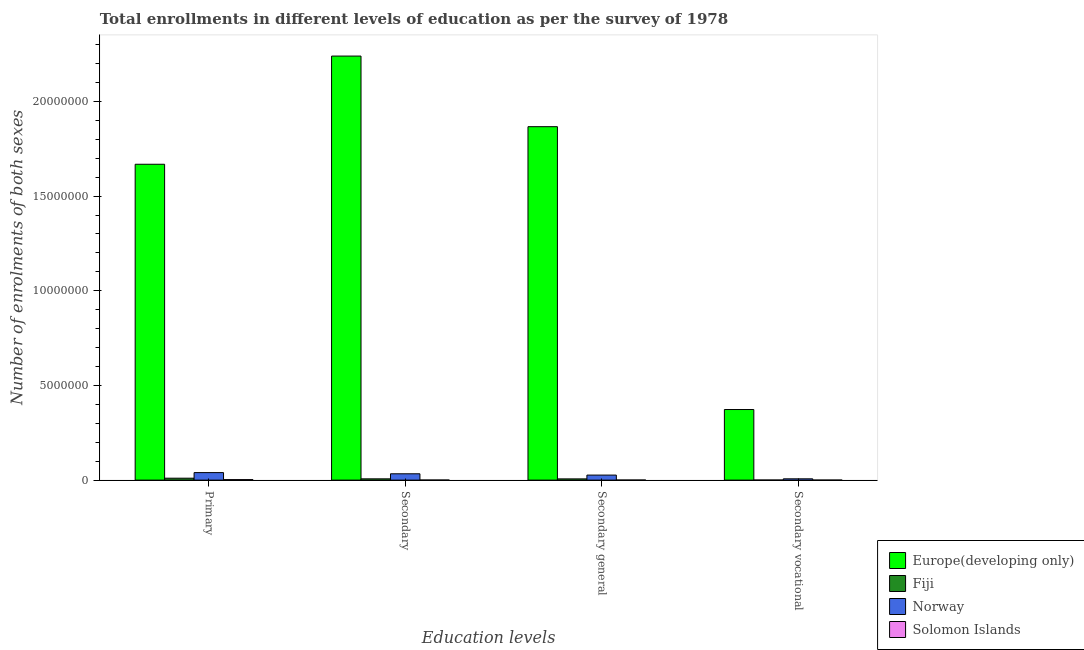How many bars are there on the 3rd tick from the left?
Ensure brevity in your answer.  4. What is the label of the 4th group of bars from the left?
Keep it short and to the point. Secondary vocational. What is the number of enrolments in secondary vocational education in Solomon Islands?
Your answer should be compact. 484. Across all countries, what is the maximum number of enrolments in secondary general education?
Provide a succinct answer. 1.87e+07. Across all countries, what is the minimum number of enrolments in secondary general education?
Provide a succinct answer. 2984. In which country was the number of enrolments in secondary education maximum?
Provide a short and direct response. Europe(developing only). In which country was the number of enrolments in secondary vocational education minimum?
Keep it short and to the point. Solomon Islands. What is the total number of enrolments in primary education in the graph?
Your answer should be very brief. 1.72e+07. What is the difference between the number of enrolments in secondary vocational education in Fiji and that in Solomon Islands?
Your answer should be very brief. 2059. What is the difference between the number of enrolments in secondary vocational education in Solomon Islands and the number of enrolments in secondary education in Fiji?
Make the answer very short. -6.68e+04. What is the average number of enrolments in secondary general education per country?
Provide a short and direct response. 4.75e+06. What is the difference between the number of enrolments in secondary general education and number of enrolments in primary education in Fiji?
Keep it short and to the point. -3.64e+04. What is the ratio of the number of enrolments in secondary general education in Solomon Islands to that in Fiji?
Provide a short and direct response. 0.05. Is the number of enrolments in primary education in Solomon Islands less than that in Europe(developing only)?
Provide a succinct answer. Yes. Is the difference between the number of enrolments in secondary vocational education in Norway and Solomon Islands greater than the difference between the number of enrolments in secondary education in Norway and Solomon Islands?
Your answer should be compact. No. What is the difference between the highest and the second highest number of enrolments in primary education?
Offer a terse response. 1.63e+07. What is the difference between the highest and the lowest number of enrolments in secondary vocational education?
Give a very brief answer. 3.73e+06. In how many countries, is the number of enrolments in secondary general education greater than the average number of enrolments in secondary general education taken over all countries?
Give a very brief answer. 1. Is it the case that in every country, the sum of the number of enrolments in primary education and number of enrolments in secondary education is greater than the number of enrolments in secondary general education?
Offer a very short reply. Yes. How many bars are there?
Provide a succinct answer. 16. How many countries are there in the graph?
Ensure brevity in your answer.  4. What is the difference between two consecutive major ticks on the Y-axis?
Your response must be concise. 5.00e+06. Does the graph contain grids?
Keep it short and to the point. No. How many legend labels are there?
Provide a short and direct response. 4. What is the title of the graph?
Provide a short and direct response. Total enrollments in different levels of education as per the survey of 1978. What is the label or title of the X-axis?
Your answer should be very brief. Education levels. What is the label or title of the Y-axis?
Your response must be concise. Number of enrolments of both sexes. What is the Number of enrolments of both sexes in Europe(developing only) in Primary?
Ensure brevity in your answer.  1.67e+07. What is the Number of enrolments of both sexes of Fiji in Primary?
Your answer should be very brief. 1.01e+05. What is the Number of enrolments of both sexes in Norway in Primary?
Your response must be concise. 3.97e+05. What is the Number of enrolments of both sexes in Solomon Islands in Primary?
Provide a succinct answer. 2.67e+04. What is the Number of enrolments of both sexes of Europe(developing only) in Secondary?
Provide a succinct answer. 2.24e+07. What is the Number of enrolments of both sexes of Fiji in Secondary?
Provide a succinct answer. 6.73e+04. What is the Number of enrolments of both sexes in Norway in Secondary?
Provide a short and direct response. 3.34e+05. What is the Number of enrolments of both sexes of Solomon Islands in Secondary?
Offer a very short reply. 3468. What is the Number of enrolments of both sexes in Europe(developing only) in Secondary general?
Make the answer very short. 1.87e+07. What is the Number of enrolments of both sexes of Fiji in Secondary general?
Keep it short and to the point. 6.48e+04. What is the Number of enrolments of both sexes in Norway in Secondary general?
Your answer should be compact. 2.66e+05. What is the Number of enrolments of both sexes in Solomon Islands in Secondary general?
Ensure brevity in your answer.  2984. What is the Number of enrolments of both sexes of Europe(developing only) in Secondary vocational?
Your response must be concise. 3.73e+06. What is the Number of enrolments of both sexes in Fiji in Secondary vocational?
Make the answer very short. 2543. What is the Number of enrolments of both sexes in Norway in Secondary vocational?
Offer a terse response. 6.87e+04. What is the Number of enrolments of both sexes of Solomon Islands in Secondary vocational?
Your answer should be very brief. 484. Across all Education levels, what is the maximum Number of enrolments of both sexes of Europe(developing only)?
Offer a very short reply. 2.24e+07. Across all Education levels, what is the maximum Number of enrolments of both sexes in Fiji?
Provide a succinct answer. 1.01e+05. Across all Education levels, what is the maximum Number of enrolments of both sexes in Norway?
Keep it short and to the point. 3.97e+05. Across all Education levels, what is the maximum Number of enrolments of both sexes in Solomon Islands?
Offer a very short reply. 2.67e+04. Across all Education levels, what is the minimum Number of enrolments of both sexes in Europe(developing only)?
Give a very brief answer. 3.73e+06. Across all Education levels, what is the minimum Number of enrolments of both sexes of Fiji?
Provide a succinct answer. 2543. Across all Education levels, what is the minimum Number of enrolments of both sexes in Norway?
Provide a succinct answer. 6.87e+04. Across all Education levels, what is the minimum Number of enrolments of both sexes of Solomon Islands?
Provide a succinct answer. 484. What is the total Number of enrolments of both sexes in Europe(developing only) in the graph?
Provide a succinct answer. 6.15e+07. What is the total Number of enrolments of both sexes in Fiji in the graph?
Make the answer very short. 2.36e+05. What is the total Number of enrolments of both sexes in Norway in the graph?
Your response must be concise. 1.07e+06. What is the total Number of enrolments of both sexes in Solomon Islands in the graph?
Keep it short and to the point. 3.37e+04. What is the difference between the Number of enrolments of both sexes in Europe(developing only) in Primary and that in Secondary?
Keep it short and to the point. -5.71e+06. What is the difference between the Number of enrolments of both sexes in Fiji in Primary and that in Secondary?
Provide a succinct answer. 3.38e+04. What is the difference between the Number of enrolments of both sexes in Norway in Primary and that in Secondary?
Provide a succinct answer. 6.23e+04. What is the difference between the Number of enrolments of both sexes in Solomon Islands in Primary and that in Secondary?
Your answer should be compact. 2.33e+04. What is the difference between the Number of enrolments of both sexes in Europe(developing only) in Primary and that in Secondary general?
Give a very brief answer. -1.98e+06. What is the difference between the Number of enrolments of both sexes in Fiji in Primary and that in Secondary general?
Offer a terse response. 3.64e+04. What is the difference between the Number of enrolments of both sexes in Norway in Primary and that in Secondary general?
Offer a terse response. 1.31e+05. What is the difference between the Number of enrolments of both sexes of Solomon Islands in Primary and that in Secondary general?
Provide a short and direct response. 2.38e+04. What is the difference between the Number of enrolments of both sexes of Europe(developing only) in Primary and that in Secondary vocational?
Your answer should be very brief. 1.30e+07. What is the difference between the Number of enrolments of both sexes in Fiji in Primary and that in Secondary vocational?
Provide a succinct answer. 9.86e+04. What is the difference between the Number of enrolments of both sexes of Norway in Primary and that in Secondary vocational?
Offer a terse response. 3.28e+05. What is the difference between the Number of enrolments of both sexes in Solomon Islands in Primary and that in Secondary vocational?
Offer a terse response. 2.63e+04. What is the difference between the Number of enrolments of both sexes of Europe(developing only) in Secondary and that in Secondary general?
Offer a terse response. 3.73e+06. What is the difference between the Number of enrolments of both sexes in Fiji in Secondary and that in Secondary general?
Ensure brevity in your answer.  2543. What is the difference between the Number of enrolments of both sexes of Norway in Secondary and that in Secondary general?
Ensure brevity in your answer.  6.87e+04. What is the difference between the Number of enrolments of both sexes of Solomon Islands in Secondary and that in Secondary general?
Make the answer very short. 484. What is the difference between the Number of enrolments of both sexes of Europe(developing only) in Secondary and that in Secondary vocational?
Offer a terse response. 1.87e+07. What is the difference between the Number of enrolments of both sexes of Fiji in Secondary and that in Secondary vocational?
Your answer should be very brief. 6.48e+04. What is the difference between the Number of enrolments of both sexes of Norway in Secondary and that in Secondary vocational?
Provide a succinct answer. 2.66e+05. What is the difference between the Number of enrolments of both sexes of Solomon Islands in Secondary and that in Secondary vocational?
Provide a short and direct response. 2984. What is the difference between the Number of enrolments of both sexes of Europe(developing only) in Secondary general and that in Secondary vocational?
Your response must be concise. 1.49e+07. What is the difference between the Number of enrolments of both sexes in Fiji in Secondary general and that in Secondary vocational?
Your response must be concise. 6.22e+04. What is the difference between the Number of enrolments of both sexes in Norway in Secondary general and that in Secondary vocational?
Provide a short and direct response. 1.97e+05. What is the difference between the Number of enrolments of both sexes of Solomon Islands in Secondary general and that in Secondary vocational?
Offer a terse response. 2500. What is the difference between the Number of enrolments of both sexes of Europe(developing only) in Primary and the Number of enrolments of both sexes of Fiji in Secondary?
Provide a succinct answer. 1.66e+07. What is the difference between the Number of enrolments of both sexes of Europe(developing only) in Primary and the Number of enrolments of both sexes of Norway in Secondary?
Provide a succinct answer. 1.63e+07. What is the difference between the Number of enrolments of both sexes in Europe(developing only) in Primary and the Number of enrolments of both sexes in Solomon Islands in Secondary?
Provide a short and direct response. 1.67e+07. What is the difference between the Number of enrolments of both sexes in Fiji in Primary and the Number of enrolments of both sexes in Norway in Secondary?
Ensure brevity in your answer.  -2.33e+05. What is the difference between the Number of enrolments of both sexes in Fiji in Primary and the Number of enrolments of both sexes in Solomon Islands in Secondary?
Provide a short and direct response. 9.77e+04. What is the difference between the Number of enrolments of both sexes in Norway in Primary and the Number of enrolments of both sexes in Solomon Islands in Secondary?
Make the answer very short. 3.93e+05. What is the difference between the Number of enrolments of both sexes of Europe(developing only) in Primary and the Number of enrolments of both sexes of Fiji in Secondary general?
Ensure brevity in your answer.  1.66e+07. What is the difference between the Number of enrolments of both sexes of Europe(developing only) in Primary and the Number of enrolments of both sexes of Norway in Secondary general?
Offer a terse response. 1.64e+07. What is the difference between the Number of enrolments of both sexes of Europe(developing only) in Primary and the Number of enrolments of both sexes of Solomon Islands in Secondary general?
Provide a succinct answer. 1.67e+07. What is the difference between the Number of enrolments of both sexes in Fiji in Primary and the Number of enrolments of both sexes in Norway in Secondary general?
Give a very brief answer. -1.65e+05. What is the difference between the Number of enrolments of both sexes of Fiji in Primary and the Number of enrolments of both sexes of Solomon Islands in Secondary general?
Provide a succinct answer. 9.82e+04. What is the difference between the Number of enrolments of both sexes of Norway in Primary and the Number of enrolments of both sexes of Solomon Islands in Secondary general?
Your response must be concise. 3.94e+05. What is the difference between the Number of enrolments of both sexes in Europe(developing only) in Primary and the Number of enrolments of both sexes in Fiji in Secondary vocational?
Your response must be concise. 1.67e+07. What is the difference between the Number of enrolments of both sexes of Europe(developing only) in Primary and the Number of enrolments of both sexes of Norway in Secondary vocational?
Your answer should be compact. 1.66e+07. What is the difference between the Number of enrolments of both sexes of Europe(developing only) in Primary and the Number of enrolments of both sexes of Solomon Islands in Secondary vocational?
Ensure brevity in your answer.  1.67e+07. What is the difference between the Number of enrolments of both sexes in Fiji in Primary and the Number of enrolments of both sexes in Norway in Secondary vocational?
Make the answer very short. 3.25e+04. What is the difference between the Number of enrolments of both sexes in Fiji in Primary and the Number of enrolments of both sexes in Solomon Islands in Secondary vocational?
Provide a succinct answer. 1.01e+05. What is the difference between the Number of enrolments of both sexes in Norway in Primary and the Number of enrolments of both sexes in Solomon Islands in Secondary vocational?
Offer a terse response. 3.96e+05. What is the difference between the Number of enrolments of both sexes of Europe(developing only) in Secondary and the Number of enrolments of both sexes of Fiji in Secondary general?
Give a very brief answer. 2.23e+07. What is the difference between the Number of enrolments of both sexes of Europe(developing only) in Secondary and the Number of enrolments of both sexes of Norway in Secondary general?
Offer a terse response. 2.21e+07. What is the difference between the Number of enrolments of both sexes in Europe(developing only) in Secondary and the Number of enrolments of both sexes in Solomon Islands in Secondary general?
Your answer should be compact. 2.24e+07. What is the difference between the Number of enrolments of both sexes in Fiji in Secondary and the Number of enrolments of both sexes in Norway in Secondary general?
Provide a succinct answer. -1.98e+05. What is the difference between the Number of enrolments of both sexes in Fiji in Secondary and the Number of enrolments of both sexes in Solomon Islands in Secondary general?
Keep it short and to the point. 6.43e+04. What is the difference between the Number of enrolments of both sexes in Norway in Secondary and the Number of enrolments of both sexes in Solomon Islands in Secondary general?
Give a very brief answer. 3.31e+05. What is the difference between the Number of enrolments of both sexes in Europe(developing only) in Secondary and the Number of enrolments of both sexes in Fiji in Secondary vocational?
Your response must be concise. 2.24e+07. What is the difference between the Number of enrolments of both sexes in Europe(developing only) in Secondary and the Number of enrolments of both sexes in Norway in Secondary vocational?
Ensure brevity in your answer.  2.23e+07. What is the difference between the Number of enrolments of both sexes of Europe(developing only) in Secondary and the Number of enrolments of both sexes of Solomon Islands in Secondary vocational?
Offer a very short reply. 2.24e+07. What is the difference between the Number of enrolments of both sexes in Fiji in Secondary and the Number of enrolments of both sexes in Norway in Secondary vocational?
Ensure brevity in your answer.  -1350. What is the difference between the Number of enrolments of both sexes of Fiji in Secondary and the Number of enrolments of both sexes of Solomon Islands in Secondary vocational?
Keep it short and to the point. 6.68e+04. What is the difference between the Number of enrolments of both sexes of Norway in Secondary and the Number of enrolments of both sexes of Solomon Islands in Secondary vocational?
Give a very brief answer. 3.34e+05. What is the difference between the Number of enrolments of both sexes in Europe(developing only) in Secondary general and the Number of enrolments of both sexes in Fiji in Secondary vocational?
Your response must be concise. 1.87e+07. What is the difference between the Number of enrolments of both sexes in Europe(developing only) in Secondary general and the Number of enrolments of both sexes in Norway in Secondary vocational?
Your answer should be very brief. 1.86e+07. What is the difference between the Number of enrolments of both sexes in Europe(developing only) in Secondary general and the Number of enrolments of both sexes in Solomon Islands in Secondary vocational?
Give a very brief answer. 1.87e+07. What is the difference between the Number of enrolments of both sexes in Fiji in Secondary general and the Number of enrolments of both sexes in Norway in Secondary vocational?
Offer a terse response. -3893. What is the difference between the Number of enrolments of both sexes in Fiji in Secondary general and the Number of enrolments of both sexes in Solomon Islands in Secondary vocational?
Your answer should be very brief. 6.43e+04. What is the difference between the Number of enrolments of both sexes of Norway in Secondary general and the Number of enrolments of both sexes of Solomon Islands in Secondary vocational?
Keep it short and to the point. 2.65e+05. What is the average Number of enrolments of both sexes of Europe(developing only) per Education levels?
Give a very brief answer. 1.54e+07. What is the average Number of enrolments of both sexes in Fiji per Education levels?
Offer a terse response. 5.90e+04. What is the average Number of enrolments of both sexes in Norway per Education levels?
Offer a terse response. 2.66e+05. What is the average Number of enrolments of both sexes of Solomon Islands per Education levels?
Your answer should be very brief. 8421.25. What is the difference between the Number of enrolments of both sexes in Europe(developing only) and Number of enrolments of both sexes in Fiji in Primary?
Ensure brevity in your answer.  1.66e+07. What is the difference between the Number of enrolments of both sexes of Europe(developing only) and Number of enrolments of both sexes of Norway in Primary?
Make the answer very short. 1.63e+07. What is the difference between the Number of enrolments of both sexes in Europe(developing only) and Number of enrolments of both sexes in Solomon Islands in Primary?
Provide a short and direct response. 1.67e+07. What is the difference between the Number of enrolments of both sexes in Fiji and Number of enrolments of both sexes in Norway in Primary?
Keep it short and to the point. -2.96e+05. What is the difference between the Number of enrolments of both sexes of Fiji and Number of enrolments of both sexes of Solomon Islands in Primary?
Your answer should be very brief. 7.44e+04. What is the difference between the Number of enrolments of both sexes of Norway and Number of enrolments of both sexes of Solomon Islands in Primary?
Your answer should be compact. 3.70e+05. What is the difference between the Number of enrolments of both sexes of Europe(developing only) and Number of enrolments of both sexes of Fiji in Secondary?
Offer a very short reply. 2.23e+07. What is the difference between the Number of enrolments of both sexes in Europe(developing only) and Number of enrolments of both sexes in Norway in Secondary?
Provide a succinct answer. 2.21e+07. What is the difference between the Number of enrolments of both sexes of Europe(developing only) and Number of enrolments of both sexes of Solomon Islands in Secondary?
Make the answer very short. 2.24e+07. What is the difference between the Number of enrolments of both sexes in Fiji and Number of enrolments of both sexes in Norway in Secondary?
Offer a terse response. -2.67e+05. What is the difference between the Number of enrolments of both sexes of Fiji and Number of enrolments of both sexes of Solomon Islands in Secondary?
Give a very brief answer. 6.39e+04. What is the difference between the Number of enrolments of both sexes of Norway and Number of enrolments of both sexes of Solomon Islands in Secondary?
Give a very brief answer. 3.31e+05. What is the difference between the Number of enrolments of both sexes of Europe(developing only) and Number of enrolments of both sexes of Fiji in Secondary general?
Provide a succinct answer. 1.86e+07. What is the difference between the Number of enrolments of both sexes in Europe(developing only) and Number of enrolments of both sexes in Norway in Secondary general?
Offer a very short reply. 1.84e+07. What is the difference between the Number of enrolments of both sexes of Europe(developing only) and Number of enrolments of both sexes of Solomon Islands in Secondary general?
Give a very brief answer. 1.87e+07. What is the difference between the Number of enrolments of both sexes in Fiji and Number of enrolments of both sexes in Norway in Secondary general?
Give a very brief answer. -2.01e+05. What is the difference between the Number of enrolments of both sexes of Fiji and Number of enrolments of both sexes of Solomon Islands in Secondary general?
Your response must be concise. 6.18e+04. What is the difference between the Number of enrolments of both sexes in Norway and Number of enrolments of both sexes in Solomon Islands in Secondary general?
Your response must be concise. 2.63e+05. What is the difference between the Number of enrolments of both sexes in Europe(developing only) and Number of enrolments of both sexes in Fiji in Secondary vocational?
Give a very brief answer. 3.73e+06. What is the difference between the Number of enrolments of both sexes in Europe(developing only) and Number of enrolments of both sexes in Norway in Secondary vocational?
Your response must be concise. 3.66e+06. What is the difference between the Number of enrolments of both sexes in Europe(developing only) and Number of enrolments of both sexes in Solomon Islands in Secondary vocational?
Make the answer very short. 3.73e+06. What is the difference between the Number of enrolments of both sexes in Fiji and Number of enrolments of both sexes in Norway in Secondary vocational?
Provide a short and direct response. -6.61e+04. What is the difference between the Number of enrolments of both sexes of Fiji and Number of enrolments of both sexes of Solomon Islands in Secondary vocational?
Give a very brief answer. 2059. What is the difference between the Number of enrolments of both sexes in Norway and Number of enrolments of both sexes in Solomon Islands in Secondary vocational?
Provide a short and direct response. 6.82e+04. What is the ratio of the Number of enrolments of both sexes in Europe(developing only) in Primary to that in Secondary?
Your answer should be very brief. 0.74. What is the ratio of the Number of enrolments of both sexes in Fiji in Primary to that in Secondary?
Your response must be concise. 1.5. What is the ratio of the Number of enrolments of both sexes of Norway in Primary to that in Secondary?
Your response must be concise. 1.19. What is the ratio of the Number of enrolments of both sexes of Solomon Islands in Primary to that in Secondary?
Make the answer very short. 7.71. What is the ratio of the Number of enrolments of both sexes of Europe(developing only) in Primary to that in Secondary general?
Your response must be concise. 0.89. What is the ratio of the Number of enrolments of both sexes of Fiji in Primary to that in Secondary general?
Ensure brevity in your answer.  1.56. What is the ratio of the Number of enrolments of both sexes in Norway in Primary to that in Secondary general?
Your answer should be compact. 1.49. What is the ratio of the Number of enrolments of both sexes in Solomon Islands in Primary to that in Secondary general?
Your answer should be very brief. 8.96. What is the ratio of the Number of enrolments of both sexes in Europe(developing only) in Primary to that in Secondary vocational?
Give a very brief answer. 4.47. What is the ratio of the Number of enrolments of both sexes of Fiji in Primary to that in Secondary vocational?
Make the answer very short. 39.78. What is the ratio of the Number of enrolments of both sexes of Norway in Primary to that in Secondary vocational?
Ensure brevity in your answer.  5.78. What is the ratio of the Number of enrolments of both sexes in Solomon Islands in Primary to that in Secondary vocational?
Ensure brevity in your answer.  55.27. What is the ratio of the Number of enrolments of both sexes in Europe(developing only) in Secondary to that in Secondary general?
Provide a short and direct response. 1.2. What is the ratio of the Number of enrolments of both sexes of Fiji in Secondary to that in Secondary general?
Your answer should be very brief. 1.04. What is the ratio of the Number of enrolments of both sexes of Norway in Secondary to that in Secondary general?
Your response must be concise. 1.26. What is the ratio of the Number of enrolments of both sexes in Solomon Islands in Secondary to that in Secondary general?
Offer a terse response. 1.16. What is the ratio of the Number of enrolments of both sexes in Europe(developing only) in Secondary to that in Secondary vocational?
Provide a succinct answer. 6.01. What is the ratio of the Number of enrolments of both sexes in Fiji in Secondary to that in Secondary vocational?
Provide a short and direct response. 26.48. What is the ratio of the Number of enrolments of both sexes of Norway in Secondary to that in Secondary vocational?
Your response must be concise. 4.87. What is the ratio of the Number of enrolments of both sexes in Solomon Islands in Secondary to that in Secondary vocational?
Give a very brief answer. 7.17. What is the ratio of the Number of enrolments of both sexes of Europe(developing only) in Secondary general to that in Secondary vocational?
Provide a short and direct response. 5.01. What is the ratio of the Number of enrolments of both sexes of Fiji in Secondary general to that in Secondary vocational?
Keep it short and to the point. 25.48. What is the ratio of the Number of enrolments of both sexes in Norway in Secondary general to that in Secondary vocational?
Provide a succinct answer. 3.87. What is the ratio of the Number of enrolments of both sexes in Solomon Islands in Secondary general to that in Secondary vocational?
Keep it short and to the point. 6.17. What is the difference between the highest and the second highest Number of enrolments of both sexes in Europe(developing only)?
Give a very brief answer. 3.73e+06. What is the difference between the highest and the second highest Number of enrolments of both sexes of Fiji?
Make the answer very short. 3.38e+04. What is the difference between the highest and the second highest Number of enrolments of both sexes of Norway?
Make the answer very short. 6.23e+04. What is the difference between the highest and the second highest Number of enrolments of both sexes of Solomon Islands?
Your answer should be compact. 2.33e+04. What is the difference between the highest and the lowest Number of enrolments of both sexes in Europe(developing only)?
Provide a short and direct response. 1.87e+07. What is the difference between the highest and the lowest Number of enrolments of both sexes of Fiji?
Your response must be concise. 9.86e+04. What is the difference between the highest and the lowest Number of enrolments of both sexes in Norway?
Provide a short and direct response. 3.28e+05. What is the difference between the highest and the lowest Number of enrolments of both sexes in Solomon Islands?
Keep it short and to the point. 2.63e+04. 